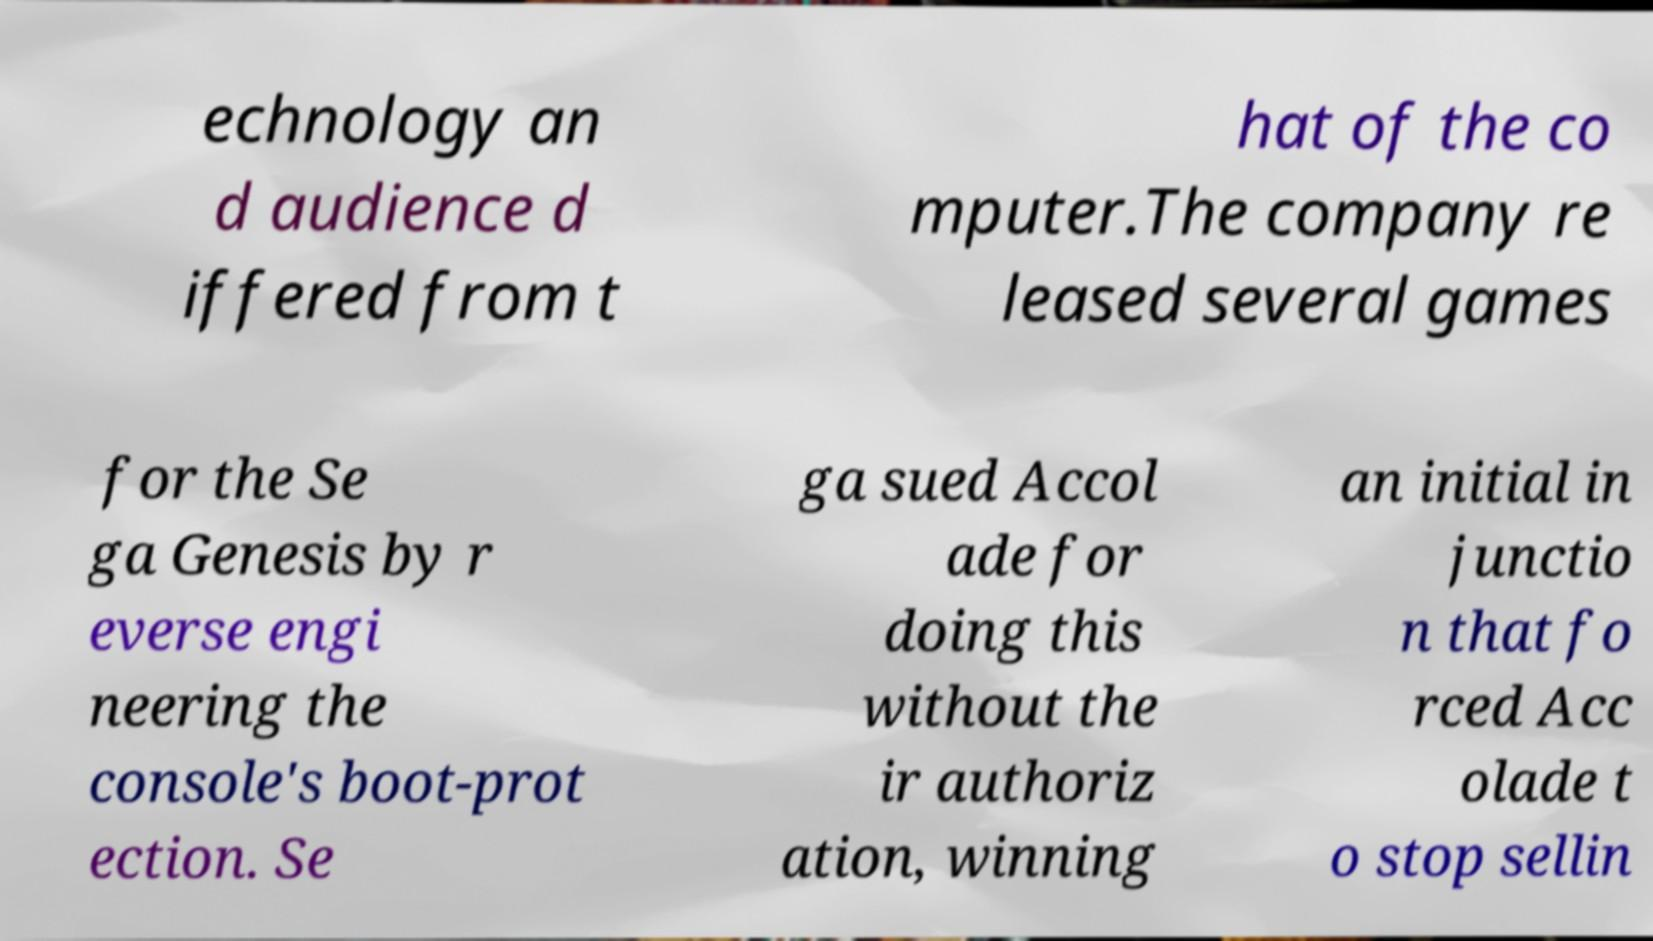Please read and relay the text visible in this image. What does it say? echnology an d audience d iffered from t hat of the co mputer.The company re leased several games for the Se ga Genesis by r everse engi neering the console's boot-prot ection. Se ga sued Accol ade for doing this without the ir authoriz ation, winning an initial in junctio n that fo rced Acc olade t o stop sellin 